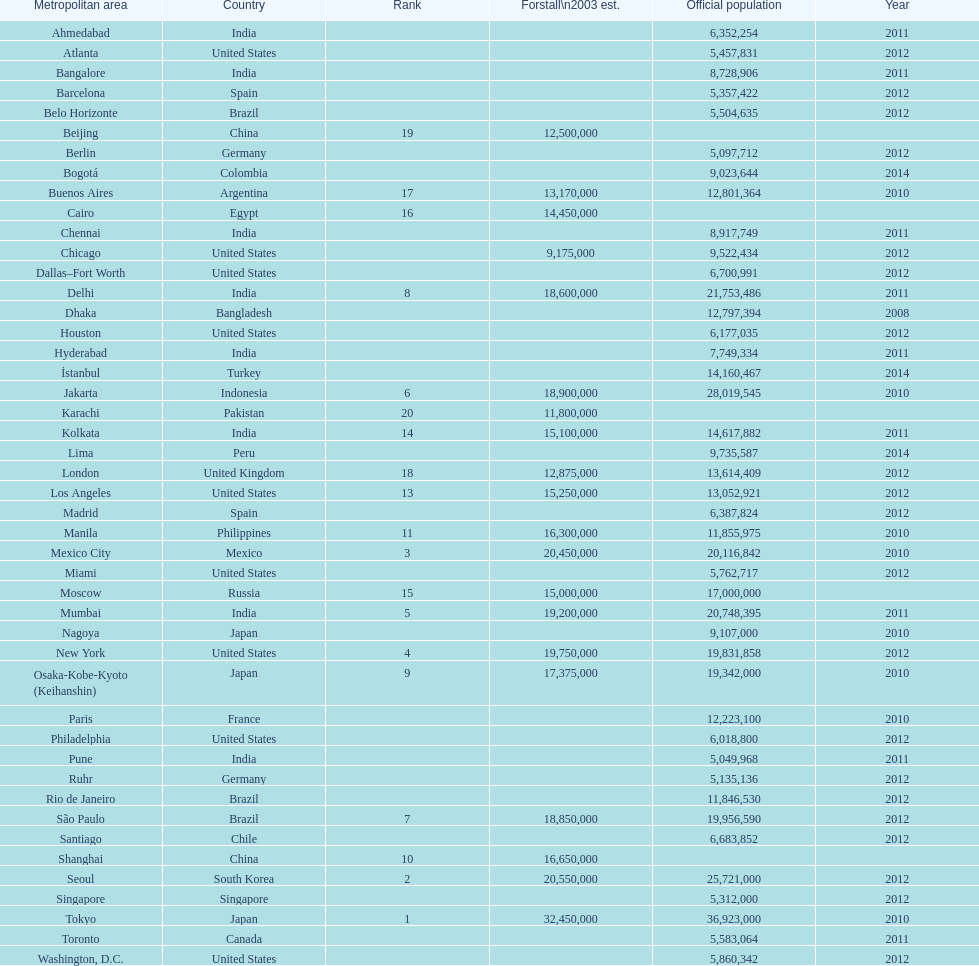What city was ranked first in 2003? Tokyo. 